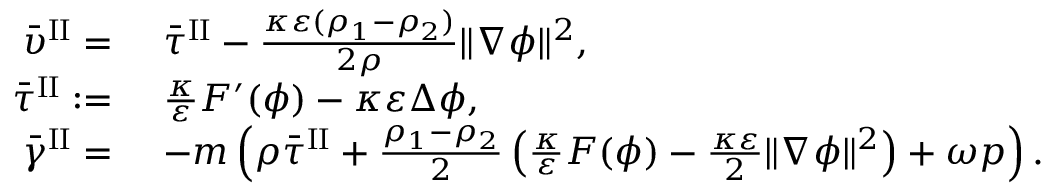Convert formula to latex. <formula><loc_0><loc_0><loc_500><loc_500>\begin{array} { r l } { \bar { \upsilon } ^ { I I } = } & { \bar { \tau } ^ { I I } - \frac { \kappa \varepsilon ( \rho _ { 1 } - \rho _ { 2 } ) } { 2 \rho } \| \nabla \phi \| ^ { 2 } , } \\ { \bar { \tau } ^ { I I } \colon = } & { \frac { \kappa } { \varepsilon } F ^ { \prime } ( \phi ) - \kappa \varepsilon \Delta \phi , } \\ { \bar { \gamma } ^ { I I } = } & { - m \left ( \rho \bar { \tau } ^ { I I } + \frac { \rho _ { 1 } - \rho _ { 2 } } { 2 } \left ( \frac { \kappa } { \varepsilon } F ( \phi ) - \frac { \kappa \varepsilon } { 2 } \| \nabla \phi \| ^ { 2 } \right ) + \omega p \right ) . } \end{array}</formula> 